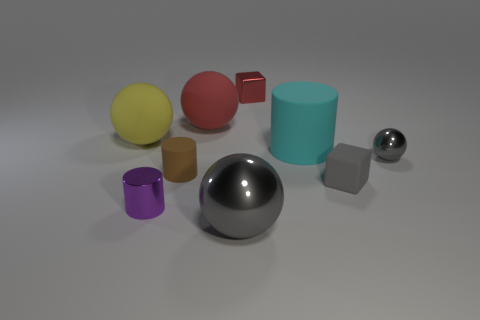Add 1 metal cylinders. How many objects exist? 10 Subtract all blue spheres. Subtract all red cubes. How many spheres are left? 4 Subtract all spheres. How many objects are left? 5 Add 7 matte blocks. How many matte blocks are left? 8 Add 8 small cubes. How many small cubes exist? 10 Subtract 0 cyan balls. How many objects are left? 9 Subtract all large red matte things. Subtract all gray things. How many objects are left? 5 